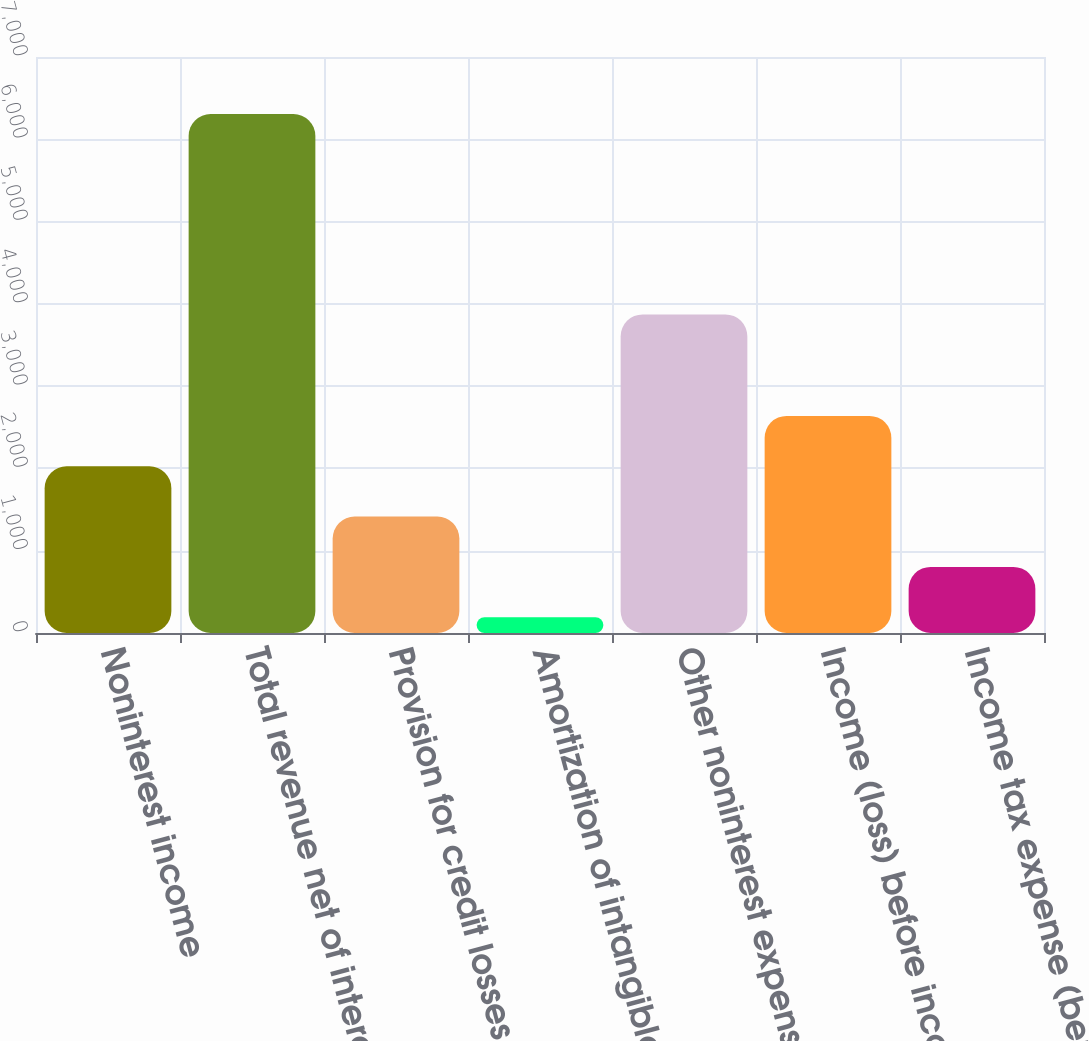Convert chart. <chart><loc_0><loc_0><loc_500><loc_500><bar_chart><fcel>Noninterest income<fcel>Total revenue net of interest<fcel>Provision for credit losses<fcel>Amortization of intangibles<fcel>Other noninterest expense<fcel>Income (loss) before income<fcel>Income tax expense (benefit)<nl><fcel>2026.5<fcel>6307<fcel>1415<fcel>192<fcel>3872<fcel>2638<fcel>803.5<nl></chart> 